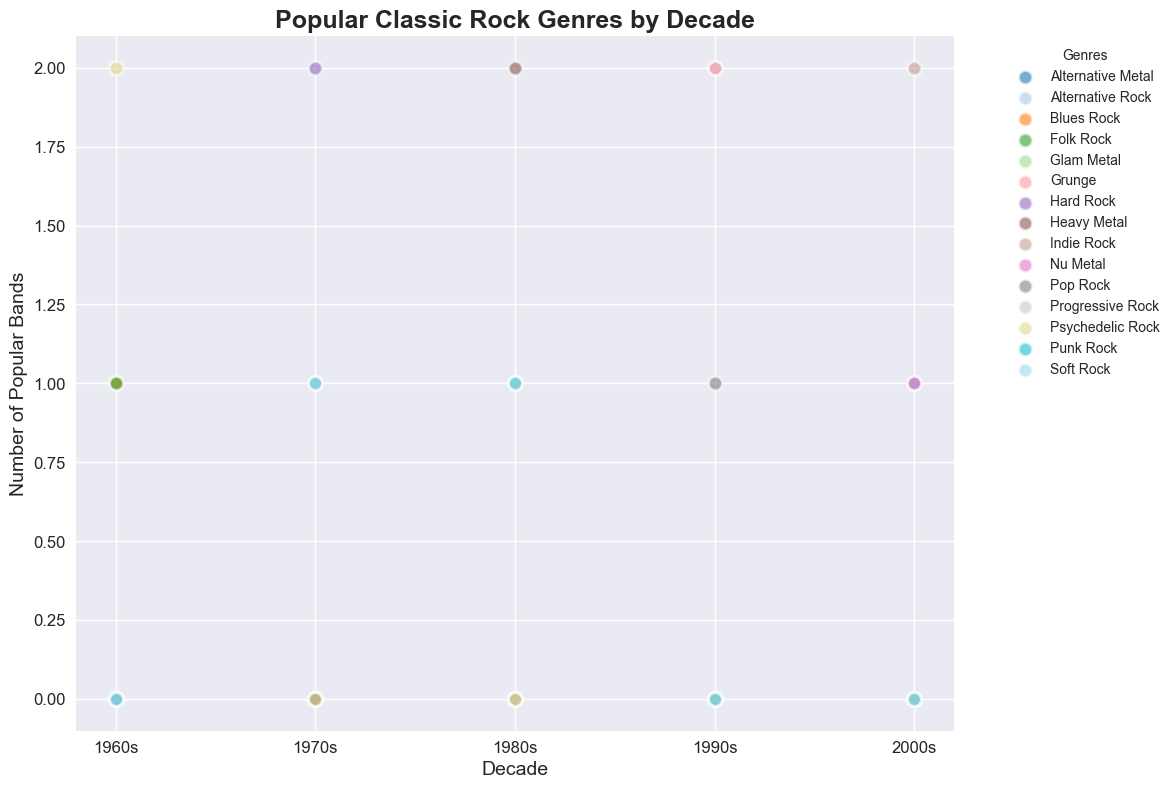Which decade had the highest number of popular bands in Grunge? First, identify the data points for Grunge bands across the decades. From the plot, we can see the number of popular Grunge bands: 1990s (2 bands). Grunge is only present in the 1990s.
Answer: 1990s Which genre had the highest number of popular bands in the 1980s? Look at the scatter points for the 1980s and compare the counts for each genre. The highest count appears for Heavy Metal with two bands.
Answer: Heavy Metal How many total bands are represented in the 1970s, and which genres are they in? Identify the scatter points of all genres in the 1970s, sum the band counts: Hard Rock (2), Progressive Rock (1), Punk Rock (1), Soft Rock (1). Total is 2+1+1+1=5.
Answer: 5 bands in Hard Rock, Progressive Rock, Punk Rock, Soft Rock Which decade shows the greatest diversity in genres, and how many different genres are represented? Count the distinct genres for each decade. The 1980s have Heavy Metal, Glam Metal, Alternative Rock, Soft Rock, Punk Rock, totaling 5 different genres, the highest among all decades.
Answer: 1980s with 5 different genres Is there a genre that consistently appears across all decades? Visually inspect the scatter points for each genre by decade. No genre appears in every decade consistently.
Answer: No Compare the number of popular bands in Folk Rock and Nu Metal. Which genre had more popular bands, and by how many? Visually identify the bands represented in Folk Rock (1960s: 1) and Nu Metal (2000s: 1). Both have the same number of bands.
Answer: Equal, 0 difference What is the difference in the number of popular Alternative Rock bands between the 1980s and 1990s? Count the bands in Alternative Rock for each decade: 1980s (1 band), 1990s (2 bands). Difference: 2 - 1 = 1.
Answer: 1 Which genre has the largest circle size in the 1970s? Observe the scatter points for the 1970s. The circle sizes are the same due to representing individual bands.
Answer: Equal sizes How does the count for Pop Rock bands compare between the 1990s and the 2000s? Identify and compare the number of Pop Rock bands: 1990s (1), 2000s (0). Pop Rock is only present in the 1990s.
Answer: 1990s > 2000s by 1 band 